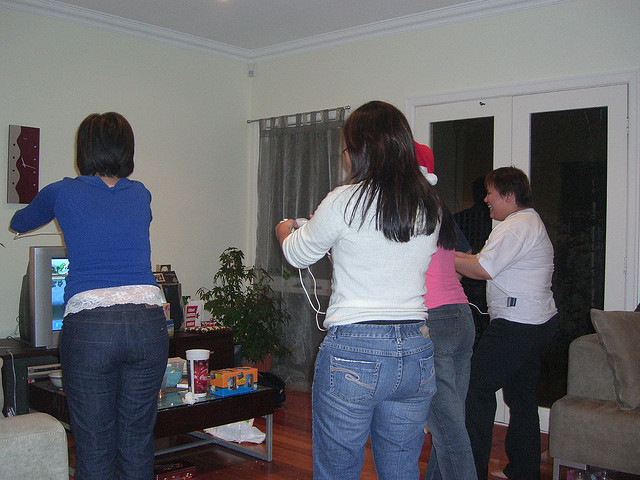How many people are there? 4 